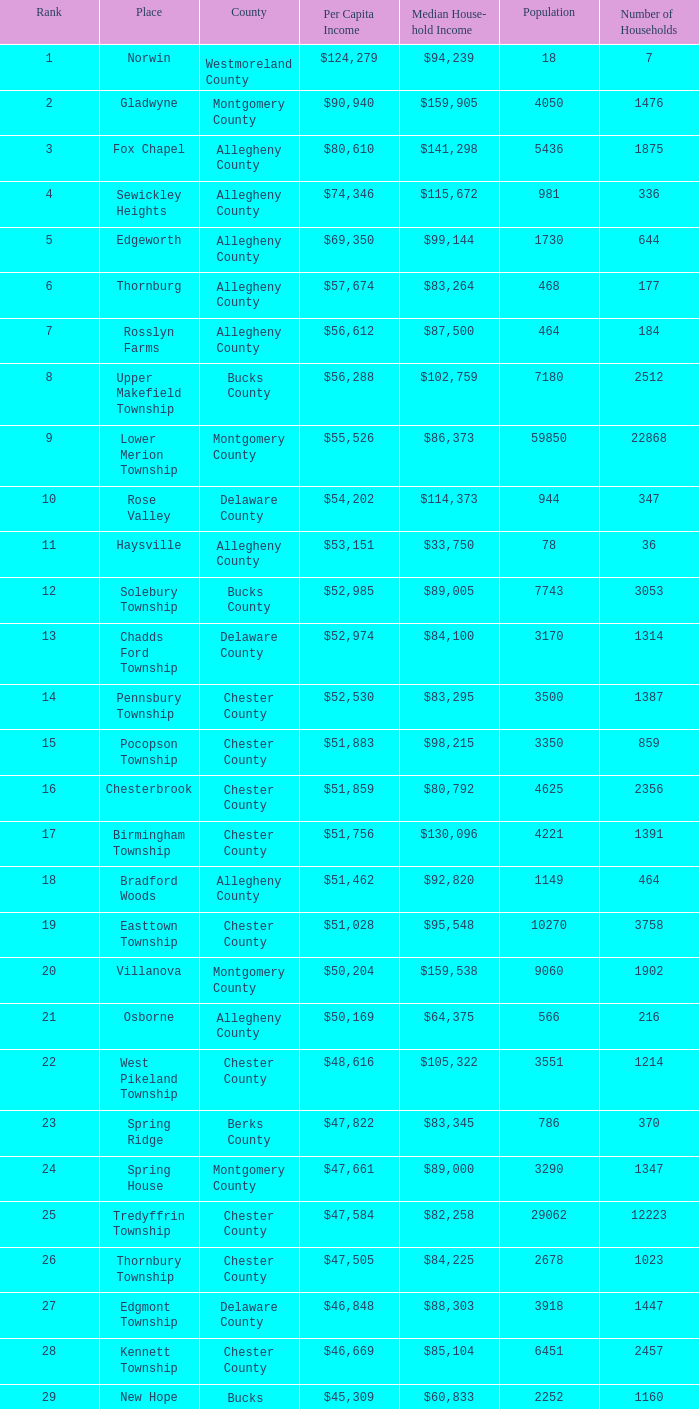Which place has a rank of 71? Wyomissing. 